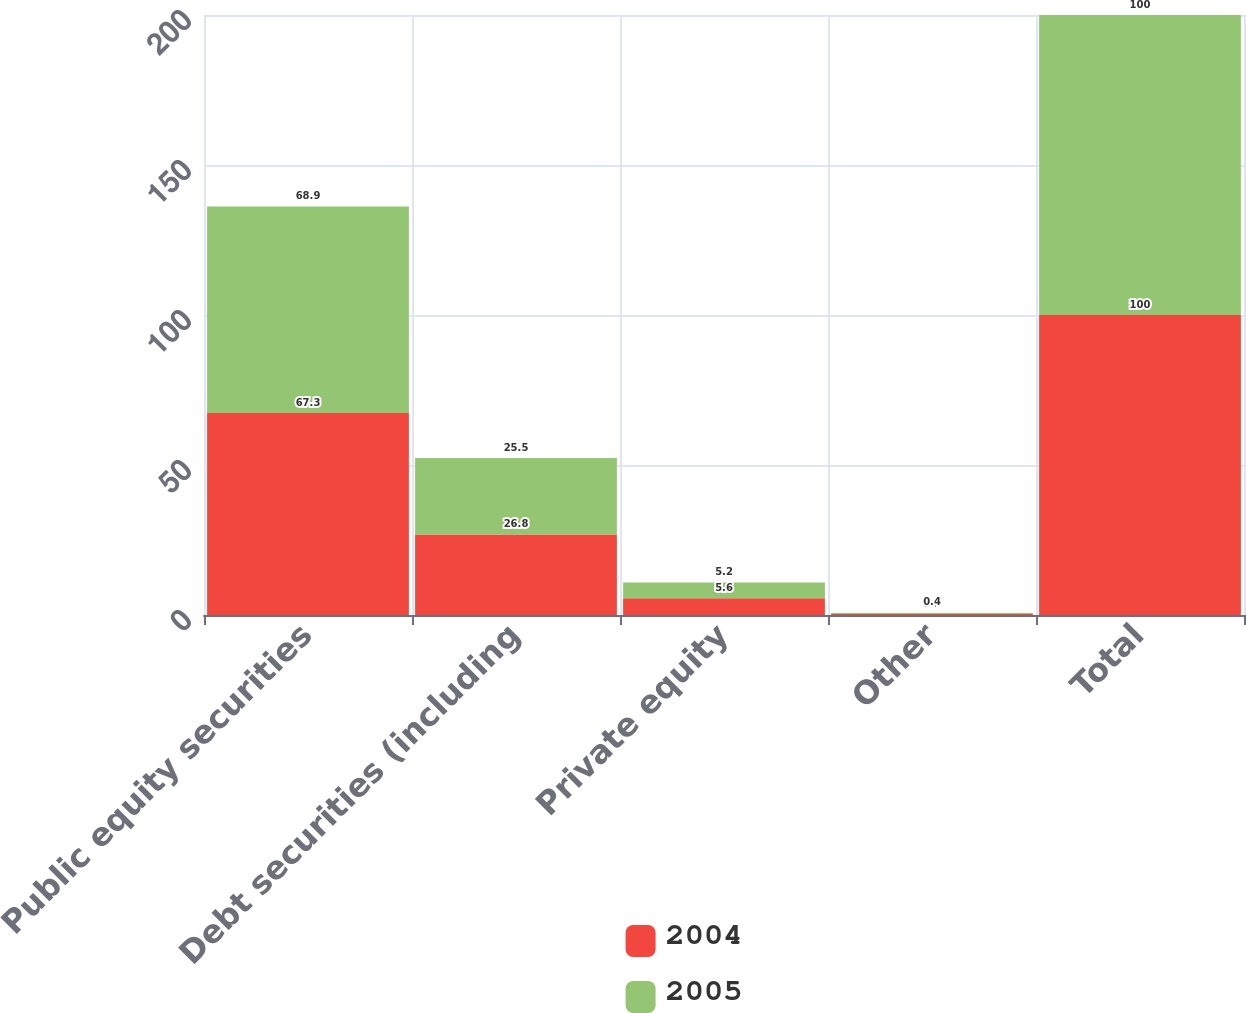Convert chart. <chart><loc_0><loc_0><loc_500><loc_500><stacked_bar_chart><ecel><fcel>Public equity securities<fcel>Debt securities (including<fcel>Private equity<fcel>Other<fcel>Total<nl><fcel>2004<fcel>67.3<fcel>26.8<fcel>5.6<fcel>0.3<fcel>100<nl><fcel>2005<fcel>68.9<fcel>25.5<fcel>5.2<fcel>0.4<fcel>100<nl></chart> 